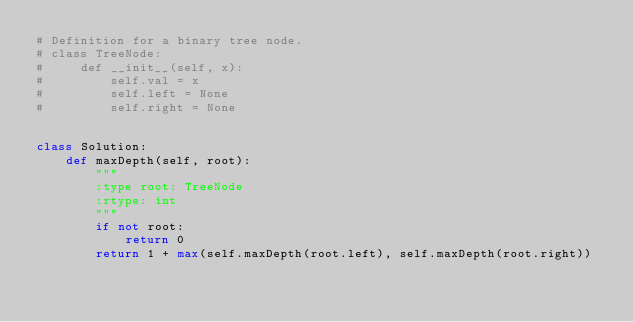Convert code to text. <code><loc_0><loc_0><loc_500><loc_500><_Python_># Definition for a binary tree node.
# class TreeNode:
#     def __init__(self, x):
#         self.val = x
#         self.left = None
#         self.right = None


class Solution:
    def maxDepth(self, root):
        """
        :type root: TreeNode
        :rtype: int
        """
        if not root:
            return 0
        return 1 + max(self.maxDepth(root.left), self.maxDepth(root.right))
</code> 